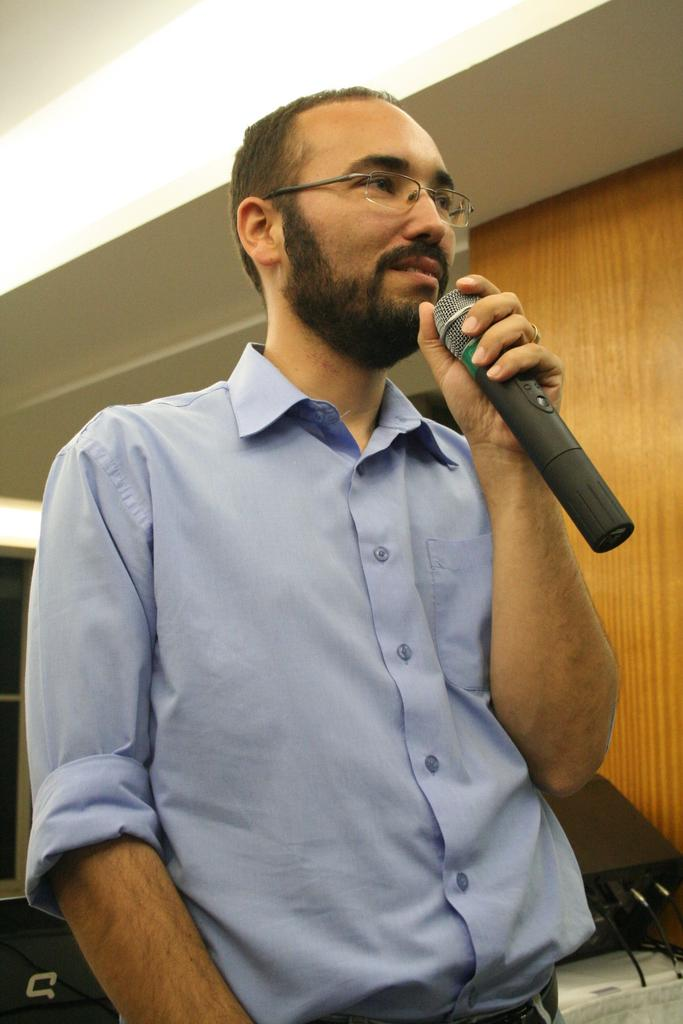What is the main subject of the image? There is a person in the image. What is the person holding in his hand? The person is holding a microphone in his hand. What type of dress is the person wearing in the image? There is no mention of a dress in the image, as the person is holding a microphone. How many cattle can be seen in the image? There are no cattle present in the image; it features a person holding a microphone. 